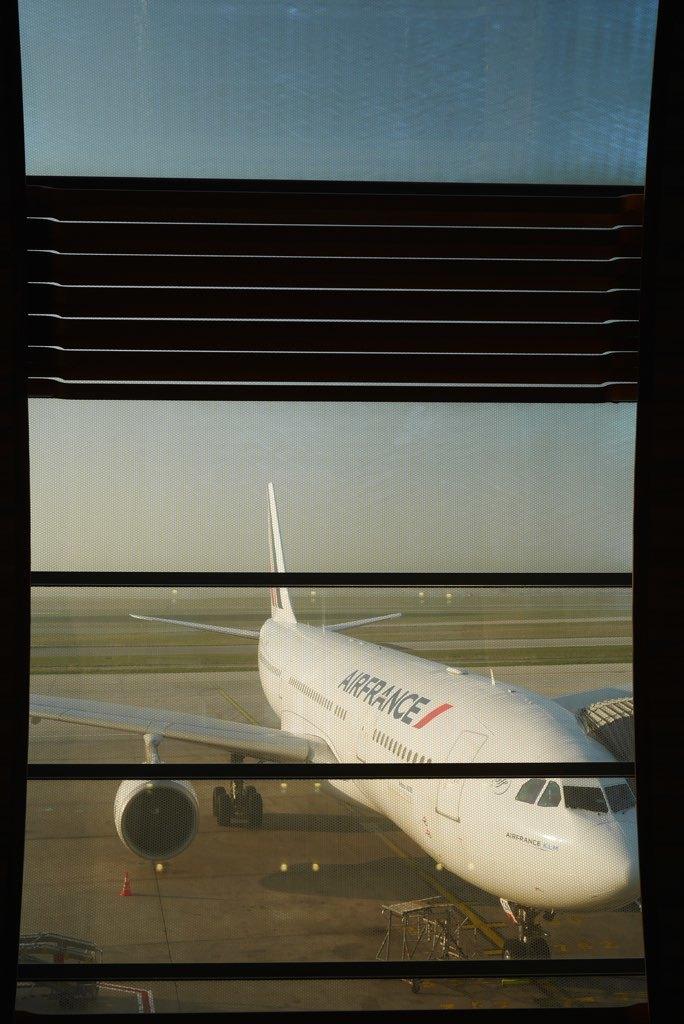Which airline is this?
Provide a succinct answer. Airfrance. Which country is this airline based in?
Your answer should be very brief. France. 